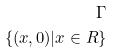<formula> <loc_0><loc_0><loc_500><loc_500>\Gamma \\ \{ ( x , 0 ) | x \in R \}</formula> 